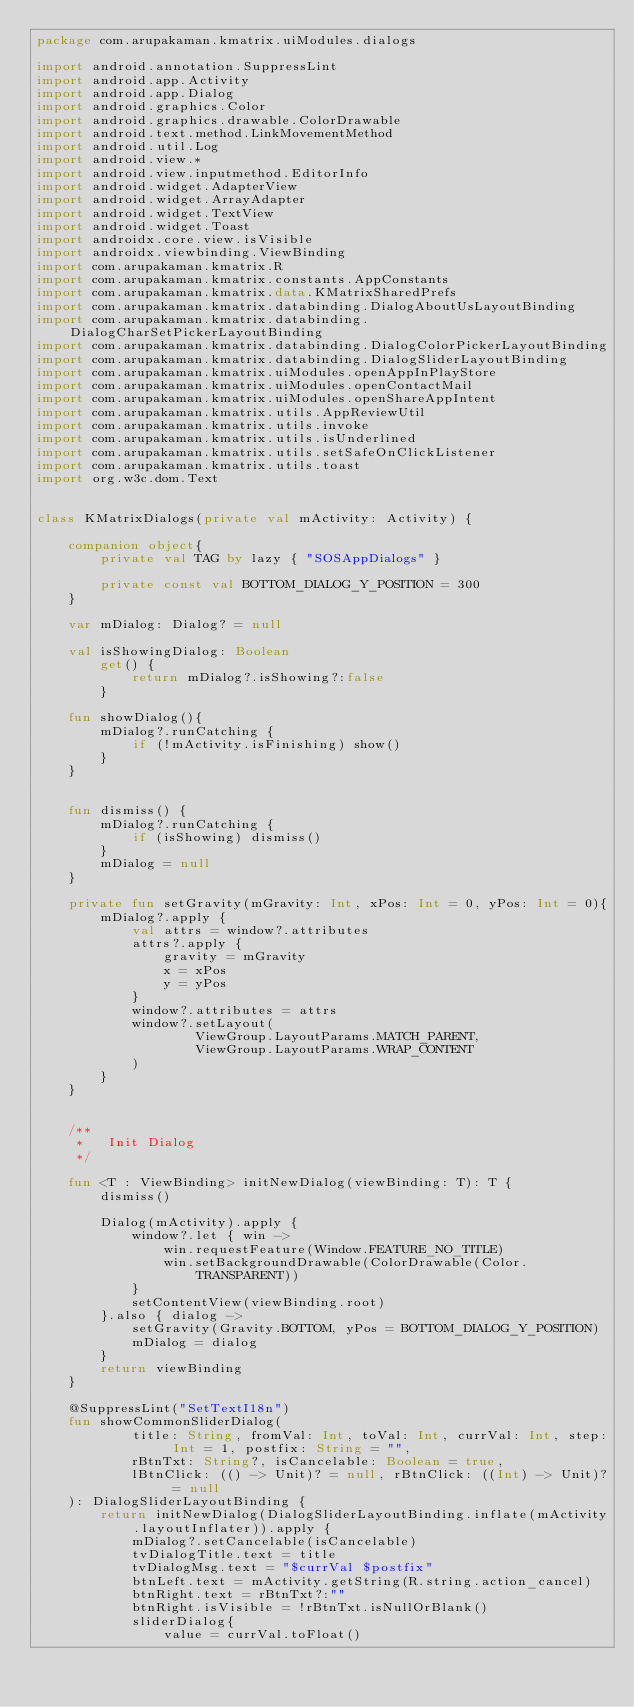Convert code to text. <code><loc_0><loc_0><loc_500><loc_500><_Kotlin_>package com.arupakaman.kmatrix.uiModules.dialogs

import android.annotation.SuppressLint
import android.app.Activity
import android.app.Dialog
import android.graphics.Color
import android.graphics.drawable.ColorDrawable
import android.text.method.LinkMovementMethod
import android.util.Log
import android.view.*
import android.view.inputmethod.EditorInfo
import android.widget.AdapterView
import android.widget.ArrayAdapter
import android.widget.TextView
import android.widget.Toast
import androidx.core.view.isVisible
import androidx.viewbinding.ViewBinding
import com.arupakaman.kmatrix.R
import com.arupakaman.kmatrix.constants.AppConstants
import com.arupakaman.kmatrix.data.KMatrixSharedPrefs
import com.arupakaman.kmatrix.databinding.DialogAboutUsLayoutBinding
import com.arupakaman.kmatrix.databinding.DialogCharSetPickerLayoutBinding
import com.arupakaman.kmatrix.databinding.DialogColorPickerLayoutBinding
import com.arupakaman.kmatrix.databinding.DialogSliderLayoutBinding
import com.arupakaman.kmatrix.uiModules.openAppInPlayStore
import com.arupakaman.kmatrix.uiModules.openContactMail
import com.arupakaman.kmatrix.uiModules.openShareAppIntent
import com.arupakaman.kmatrix.utils.AppReviewUtil
import com.arupakaman.kmatrix.utils.invoke
import com.arupakaman.kmatrix.utils.isUnderlined
import com.arupakaman.kmatrix.utils.setSafeOnClickListener
import com.arupakaman.kmatrix.utils.toast
import org.w3c.dom.Text


class KMatrixDialogs(private val mActivity: Activity) {

    companion object{
        private val TAG by lazy { "SOSAppDialogs" }

        private const val BOTTOM_DIALOG_Y_POSITION = 300
    }

    var mDialog: Dialog? = null

    val isShowingDialog: Boolean
        get() {
            return mDialog?.isShowing?:false
        }

    fun showDialog(){
        mDialog?.runCatching {
            if (!mActivity.isFinishing) show()
        }
    }


    fun dismiss() {
        mDialog?.runCatching {
            if (isShowing) dismiss()
        }
        mDialog = null
    }

    private fun setGravity(mGravity: Int, xPos: Int = 0, yPos: Int = 0){
        mDialog?.apply {
            val attrs = window?.attributes
            attrs?.apply {
                gravity = mGravity
                x = xPos
                y = yPos
            }
            window?.attributes = attrs
            window?.setLayout(
                    ViewGroup.LayoutParams.MATCH_PARENT,
                    ViewGroup.LayoutParams.WRAP_CONTENT
            )
        }
    }


    /**
     *   Init Dialog
     */

    fun <T : ViewBinding> initNewDialog(viewBinding: T): T {
        dismiss()

        Dialog(mActivity).apply {
            window?.let { win ->
                win.requestFeature(Window.FEATURE_NO_TITLE)
                win.setBackgroundDrawable(ColorDrawable(Color.TRANSPARENT))
            }
            setContentView(viewBinding.root)
        }.also { dialog ->
            setGravity(Gravity.BOTTOM, yPos = BOTTOM_DIALOG_Y_POSITION)
            mDialog = dialog
        }
        return viewBinding
    }

    @SuppressLint("SetTextI18n")
    fun showCommonSliderDialog(
            title: String, fromVal: Int, toVal: Int, currVal: Int, step: Int = 1, postfix: String = "",
            rBtnTxt: String?, isCancelable: Boolean = true,
            lBtnClick: (() -> Unit)? = null, rBtnClick: ((Int) -> Unit)? = null
    ): DialogSliderLayoutBinding {
        return initNewDialog(DialogSliderLayoutBinding.inflate(mActivity.layoutInflater)).apply {
            mDialog?.setCancelable(isCancelable)
            tvDialogTitle.text = title
            tvDialogMsg.text = "$currVal $postfix"
            btnLeft.text = mActivity.getString(R.string.action_cancel)
            btnRight.text = rBtnTxt?:""
            btnRight.isVisible = !rBtnTxt.isNullOrBlank()
            sliderDialog{
                value = currVal.toFloat()</code> 